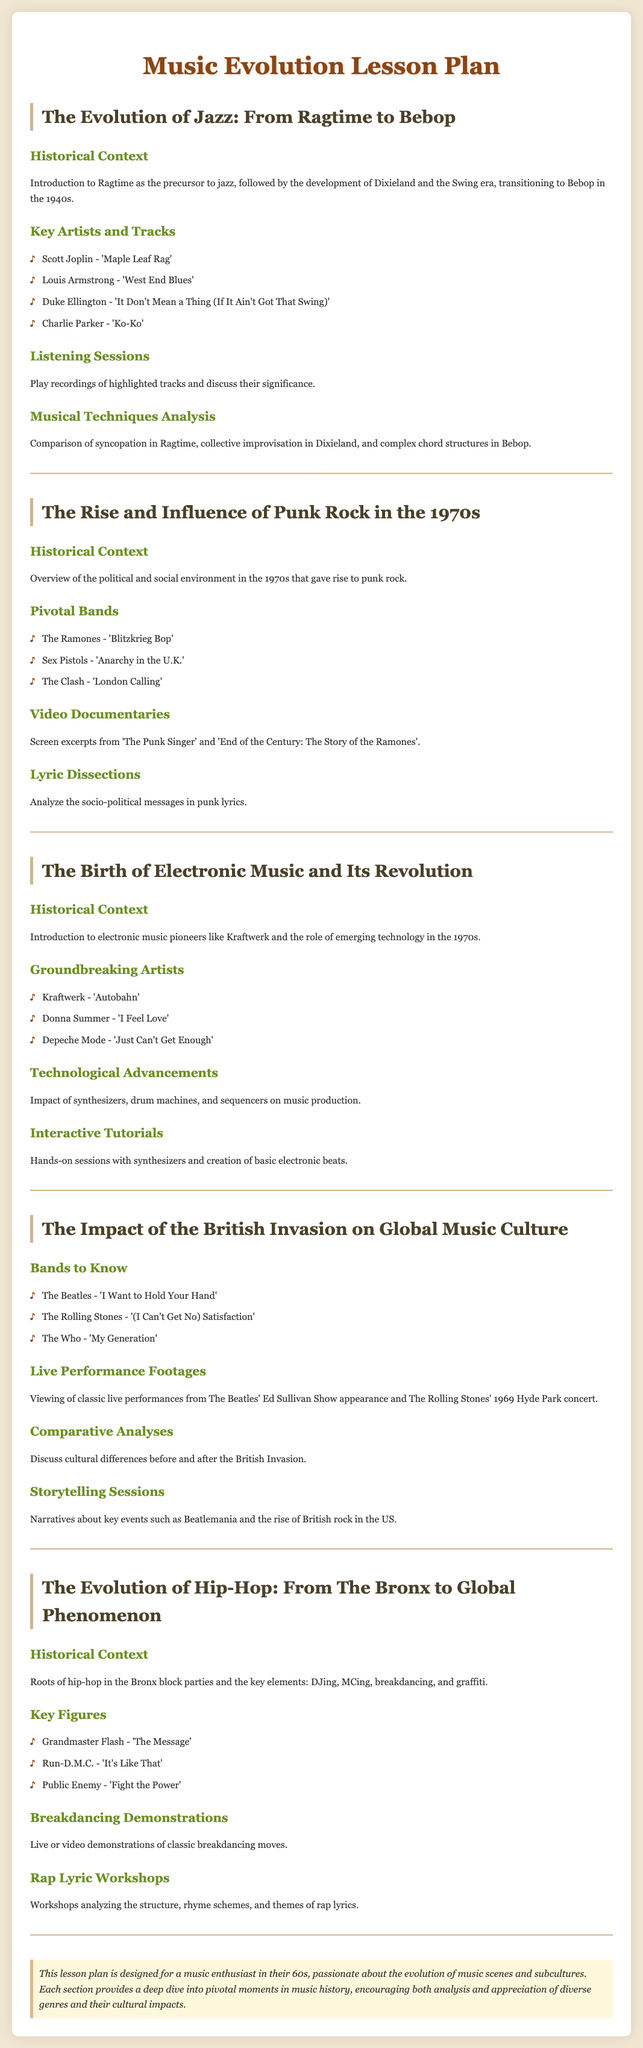What is the first lesson plan about? The first lesson plan focuses on the evolution of jazz music from its early forms to more modern styles, tracing its historical development and key artists.
Answer: The Evolution of Jazz: From Ragtime to Bebop Who is a key artist associated with punk rock? The lesson mentions several pivotal bands, one of which is the Ramones.
Answer: The Ramones What technological advancements are discussed in the electronic music lesson? The lesson highlights the impact of several tools essential to the genre, including synths and drum machines.
Answer: Synthesizers, drum machines Which band is highlighted for their song "I Want to Hold Your Hand"? The band known for that iconic track is discussed in the British Invasion lesson as a primary example.
Answer: The Beatles What cultural elements are significant in the evolution of hip-hop? The hip-hop lesson outlines the foundational aspects that began the genre.
Answer: DJing, MCing, breakdancing, graffiti Name a significant track from the Swing era. One of the songs mentioned that connects to this time period is discussed in the jazz lesson plan.
Answer: 'It Don't Mean a Thing (If It Ain't Got That Swing)' Which documentary is referenced in the punk rock lesson plan? The lesson includes screenings of specific documentaries that cover the punk rock era.
Answer: The Punk Singer What kind of workshop is included in the hip-hop lesson plan? The plan features an interactive component where students engage deeply with lyrical technique.
Answer: Rap lyric workshops 